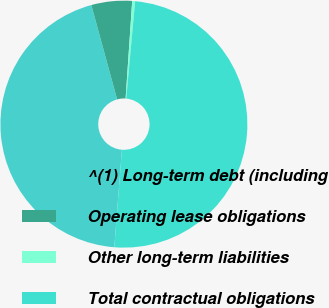<chart> <loc_0><loc_0><loc_500><loc_500><pie_chart><fcel>^(1) Long-term debt (including<fcel>Operating lease obligations<fcel>Other long-term liabilities<fcel>Total contractual obligations<nl><fcel>44.52%<fcel>5.32%<fcel>0.38%<fcel>49.79%<nl></chart> 